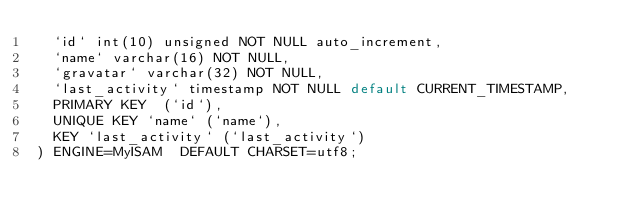<code> <loc_0><loc_0><loc_500><loc_500><_SQL_>  `id` int(10) unsigned NOT NULL auto_increment,
  `name` varchar(16) NOT NULL,
  `gravatar` varchar(32) NOT NULL,
  `last_activity` timestamp NOT NULL default CURRENT_TIMESTAMP,
  PRIMARY KEY  (`id`),
  UNIQUE KEY `name` (`name`),
  KEY `last_activity` (`last_activity`)
) ENGINE=MyISAM  DEFAULT CHARSET=utf8;
</code> 